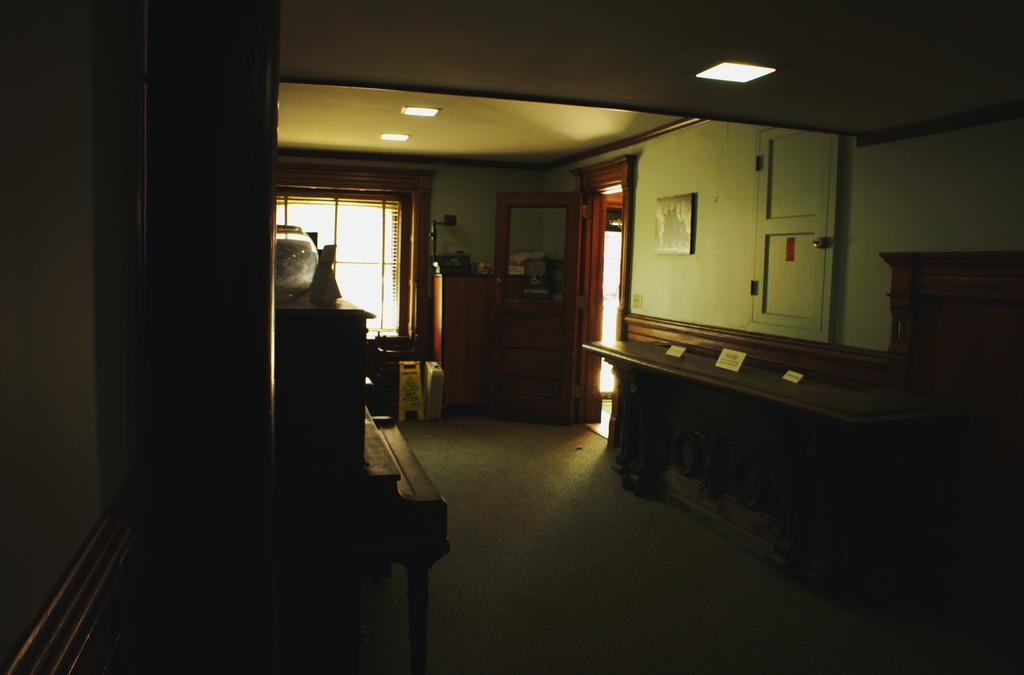In one or two sentences, can you explain what this image depicts? In this picture I can see inner view of a room and I can see blinds to the window and a door and I can see few lights on the ceiling and looks like a frame on the wall and I can see caution board on the ground and looks like table on the left side of the picture. 